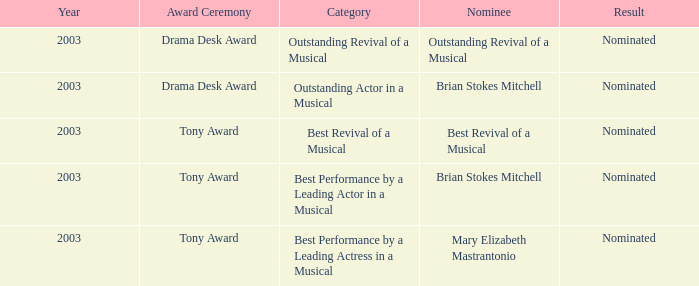What was the consequence for the nomination of best revival of a musical? Nominated. 